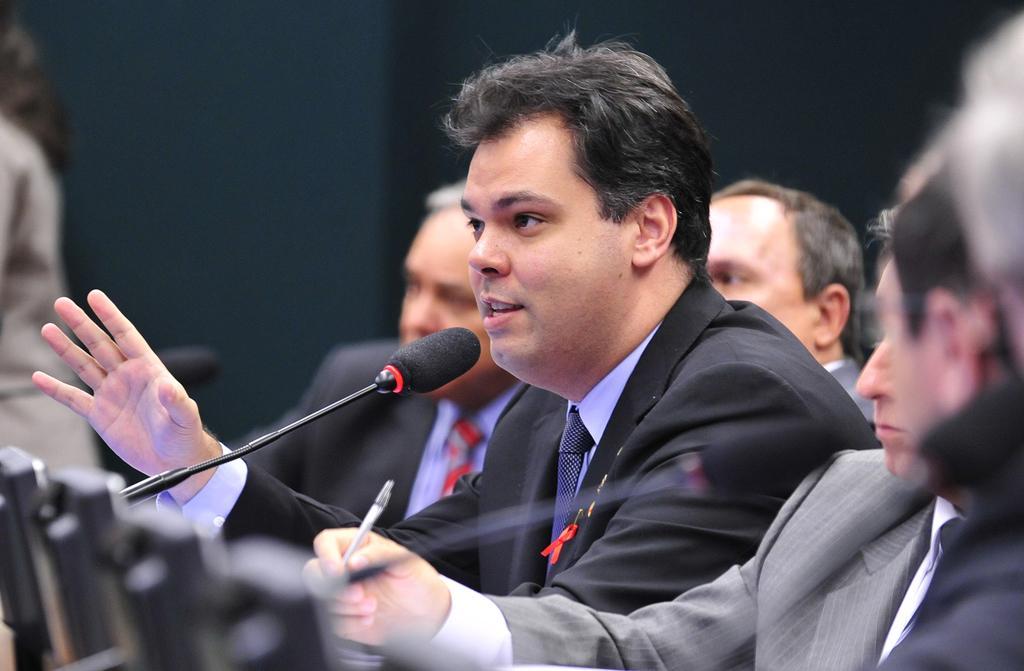Can you describe this image briefly? In the center of the image we can see a man is sitting and talking and wearing a suit. In the bottom left corner we can see the screens, mics with stands. In the background of the image we can see some people are sitting on the chairs and a man is holding a pen. On the left side of the image we can see a person is standing. At the top of the image we can see the wall. 